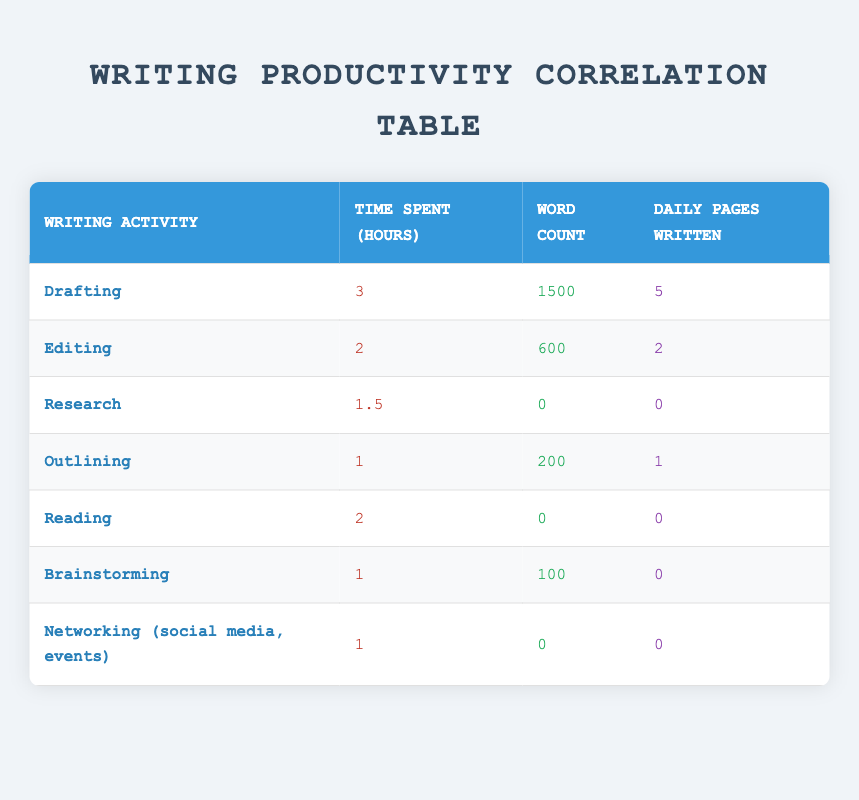What writing activity had the highest word count? The table shows that the "Drafting" activity had a word count of 1500, which is higher than any other activity listed.
Answer: Drafting What is the total time spent on writing activities that resulted in a non-zero word count? Adding the time spent on "Drafting" (3 hours), "Editing" (2 hours), and "Outlining" (1 hour) gives a total of 3 + 2 + 1 = 6 hours. The other activities contribute zero word counts, so the answer is based only on these three activities.
Answer: 6 hours Is there any writing activity that involves time spent without resulting in any word production? According to the table, there are three activities: "Research," "Reading," and "Networking" which all show a word count of 0 despite having time spent.
Answer: Yes What is the average daily pages written across all writing activities? The total daily pages written from all activities is 5 (Drafting) + 2 (Editing) + 0 (Research) + 1 (Outlining) + 0 (Reading) + 0 (Brainstorming) + 0 (Networking) = 8 pages. Since there are 7 activities, the average is 8/7 = approximately 1.14.
Answer: Approximately 1.14 Which writing activities contributed to the highest daily pages written? The top performing activities in terms of daily pages are "Drafting" with 5 pages and "Editing" with 2 pages. The next highest is "Outlining" with only 1 page.
Answer: Drafting and Editing What is the difference in daily pages written between the highest and lowest writing activities? The highest is "Drafting" with 5 pages and the lowest is "Networking," "Brainstorming," "Reading," and "Research," which all have 0 pages written. Therefore, the difference is 5 - 0 = 5 pages.
Answer: 5 pages How much time was spent on activities that resulted in no daily pages written? The activities with zero daily pages are "Research" (1.5 hours), "Reading" (2 hours), "Brainstorming" (1 hour), and "Networking" (1 hour). The total time is 1.5 + 2 + 1 + 1 = 5.5 hours.
Answer: 5.5 hours Is the time spent on "Editing" greater than that spent on "Outlining"? Comparing the two, "Editing" has 2 hours and "Outlining" has 1 hour. Since 2 hours is greater than 1 hour, the answer is yes.
Answer: Yes 